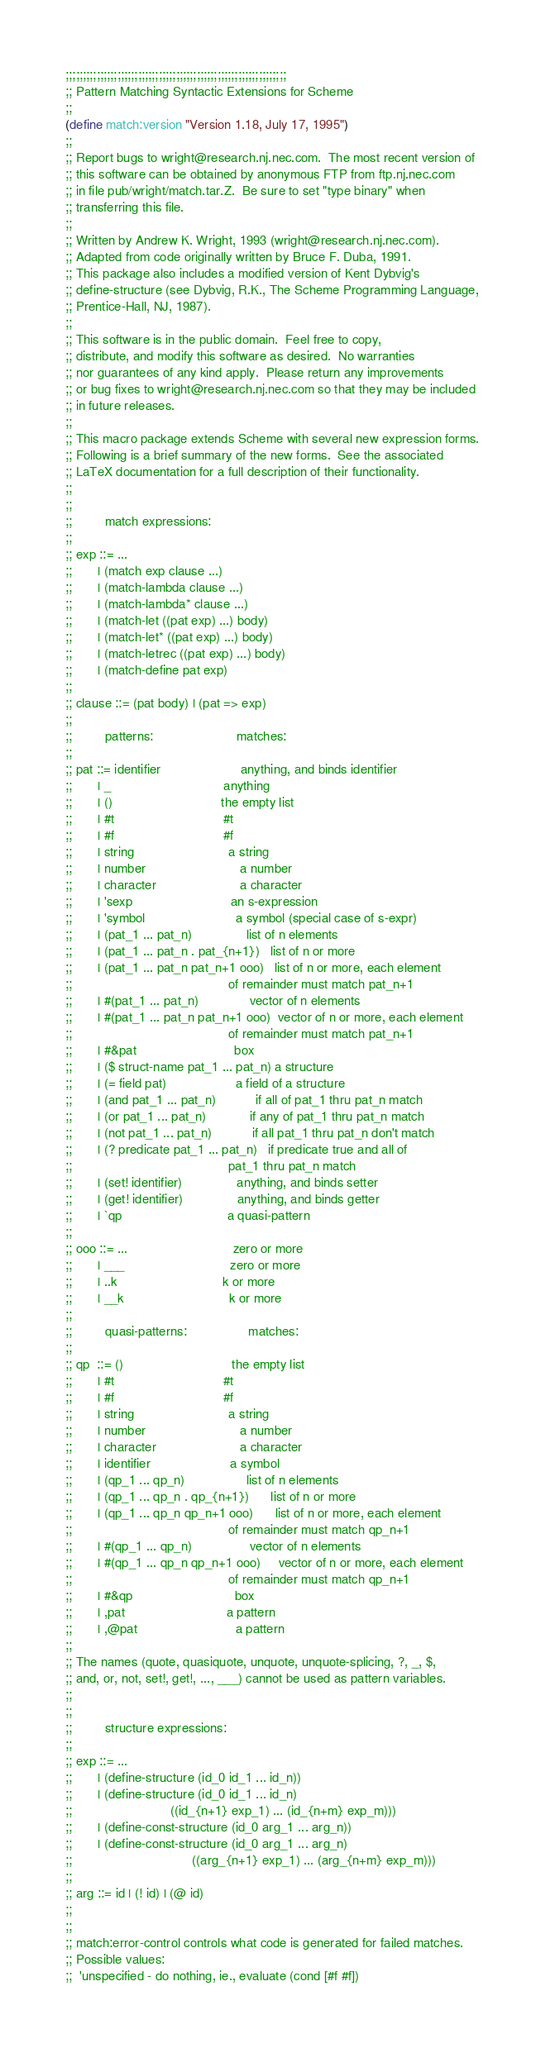<code> <loc_0><loc_0><loc_500><loc_500><_Scheme_>;;;;;;;;;;;;;;;;;;;;;;;;;;;;;;;;;;;;;;;;;;;;;;;;;;;;;;;;;;;;;;;;
;; Pattern Matching Syntactic Extensions for Scheme
;;
(define match:version "Version 1.18, July 17, 1995")
;;
;; Report bugs to wright@research.nj.nec.com.  The most recent version of
;; this software can be obtained by anonymous FTP from ftp.nj.nec.com
;; in file pub/wright/match.tar.Z.  Be sure to set "type binary" when
;; transferring this file.
;;
;; Written by Andrew K. Wright, 1993 (wright@research.nj.nec.com).
;; Adapted from code originally written by Bruce F. Duba, 1991.
;; This package also includes a modified version of Kent Dybvig's
;; define-structure (see Dybvig, R.K., The Scheme Programming Language,
;; Prentice-Hall, NJ, 1987).
;;
;; This software is in the public domain.  Feel free to copy,
;; distribute, and modify this software as desired.  No warranties
;; nor guarantees of any kind apply.  Please return any improvements
;; or bug fixes to wright@research.nj.nec.com so that they may be included
;; in future releases.
;;
;; This macro package extends Scheme with several new expression forms.
;; Following is a brief summary of the new forms.  See the associated
;; LaTeX documentation for a full description of their functionality.
;;
;;
;;         match expressions:
;;
;; exp ::= ...
;;       | (match exp clause ...)
;;       | (match-lambda clause ...)
;;       | (match-lambda* clause ...)
;;       | (match-let ((pat exp) ...) body)
;;       | (match-let* ((pat exp) ...) body)
;;       | (match-letrec ((pat exp) ...) body)
;;       | (match-define pat exp)
;;
;; clause ::= (pat body) | (pat => exp)
;;
;;         patterns:                       matches:
;;
;; pat ::= identifier                      anything, and binds identifier
;;       | _                               anything
;;       | ()                              the empty list
;;       | #t                              #t
;;       | #f                              #f
;;       | string                          a string
;;       | number                          a number
;;       | character                       a character
;;       | 'sexp                           an s-expression
;;       | 'symbol                         a symbol (special case of s-expr)
;;       | (pat_1 ... pat_n)               list of n elements
;;       | (pat_1 ... pat_n . pat_{n+1})   list of n or more
;;       | (pat_1 ... pat_n pat_n+1 ooo)   list of n or more, each element
;;                                           of remainder must match pat_n+1
;;       | #(pat_1 ... pat_n)              vector of n elements
;;       | #(pat_1 ... pat_n pat_n+1 ooo)  vector of n or more, each element
;;                                           of remainder must match pat_n+1
;;       | #&pat                           box
;;       | ($ struct-name pat_1 ... pat_n) a structure
;;       | (= field pat)                   a field of a structure
;;       | (and pat_1 ... pat_n)           if all of pat_1 thru pat_n match
;;       | (or pat_1 ... pat_n)            if any of pat_1 thru pat_n match
;;       | (not pat_1 ... pat_n)           if all pat_1 thru pat_n don't match
;;       | (? predicate pat_1 ... pat_n)   if predicate true and all of
;;                                           pat_1 thru pat_n match
;;       | (set! identifier)               anything, and binds setter
;;       | (get! identifier)               anything, and binds getter
;;       | `qp                             a quasi-pattern
;;
;; ooo ::= ...                             zero or more
;;       | ___                             zero or more
;;       | ..k                             k or more
;;       | __k                             k or more
;;
;;         quasi-patterns:                 matches:
;;
;; qp  ::= ()                              the empty list
;;       | #t                              #t
;;       | #f                              #f
;;       | string                          a string
;;       | number                          a number
;;       | character                       a character
;;       | identifier                      a symbol
;;       | (qp_1 ... qp_n)                 list of n elements
;;       | (qp_1 ... qp_n . qp_{n+1})      list of n or more
;;       | (qp_1 ... qp_n qp_n+1 ooo)      list of n or more, each element
;;                                           of remainder must match qp_n+1
;;       | #(qp_1 ... qp_n)                vector of n elements
;;       | #(qp_1 ... qp_n qp_n+1 ooo)     vector of n or more, each element
;;                                           of remainder must match qp_n+1
;;       | #&qp                            box
;;       | ,pat                            a pattern
;;       | ,@pat                           a pattern
;;
;; The names (quote, quasiquote, unquote, unquote-splicing, ?, _, $,
;; and, or, not, set!, get!, ..., ___) cannot be used as pattern variables.
;;
;;
;;         structure expressions:
;;
;; exp ::= ...
;;       | (define-structure (id_0 id_1 ... id_n))
;;       | (define-structure (id_0 id_1 ... id_n)
;;                           ((id_{n+1} exp_1) ... (id_{n+m} exp_m)))
;;       | (define-const-structure (id_0 arg_1 ... arg_n))
;;       | (define-const-structure (id_0 arg_1 ... arg_n)
;;                                 ((arg_{n+1} exp_1) ... (arg_{n+m} exp_m)))
;;
;; arg ::= id | (! id) | (@ id)
;;
;;
;; match:error-control controls what code is generated for failed matches.
;; Possible values:
;;  'unspecified - do nothing, ie., evaluate (cond [#f #f])</code> 